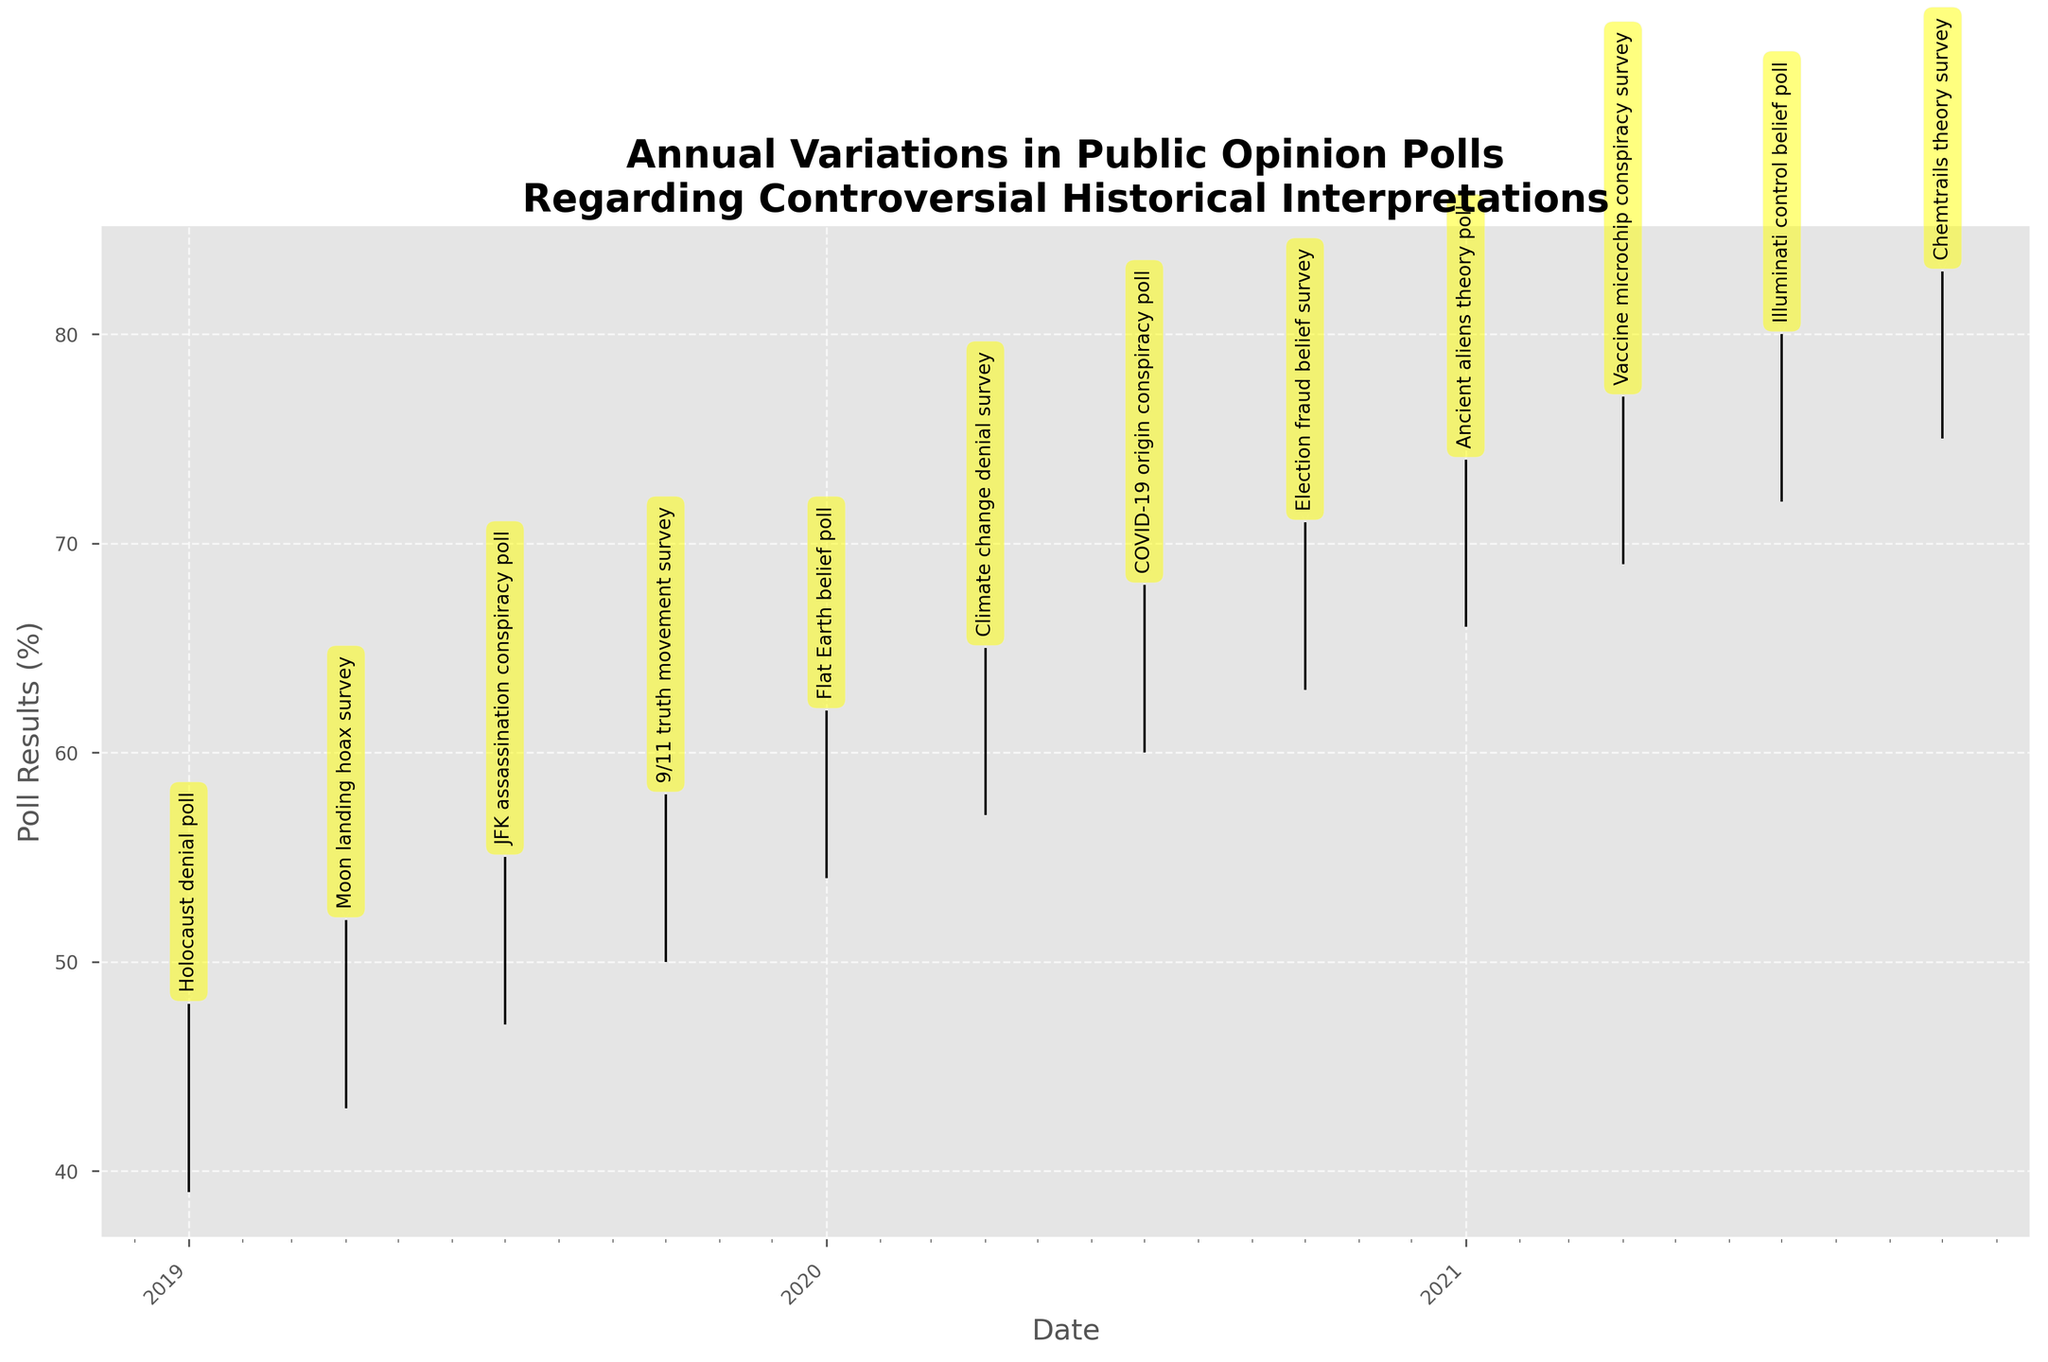What is the title of the figure? The title is typically displayed at the top of the figure. In this case, it states "Annual Variations in Public Opinion Polls Regarding Controversial Historical Interpretations".
Answer: Annual Variations in Public Opinion Polls Regarding Controversial Historical Interpretations What is the highest poll result recorded in the data? To find the highest poll result, look for the highest "High" value in the OHLC chart, which is 83% for the Chemtrails theory survey.
Answer: 83% During which event did the public opinion poll record the lowest "Low" value? Observe the "Low" values across the chart and find the one with the smallest value, which is 39% during the Holocaust denial poll.
Answer: Holocaust denial poll What is the difference between the closing values of the first and last events on the chart? The first event (Holocaust denial poll) has a closing value of 45, and the last event (Chemtrails theory survey) has a closing value of 81. Subtract the former from the latter (81 - 45).
Answer: 36 Which event has the greatest range from the lowest to the highest poll result within its period? Calculating the range (High - Low) for each event, the Moon landing hoax survey has the greatest range: (52 - 43) = 9.
Answer: Moon landing hoax survey How many public opinion polls showed an increase in the closing value compared to the previous event? Comparing the closing values between consecutive events, there are 11 instances of increase (45 to 50, 50 to 53, 53 to 56, 56 to 59, 59 to 63, 63 to 66, 66 to 69, 69 to 72, 72 to 75, 75 to 78, 78 to 81).
Answer: 11 What is the average opening value of polls conducted in the year 2020? The opening values for 2020 are (56, 59, 63, 66). Summing them gives 244, and dividing by the number of events (4) results in an average of 61.
Answer: 61 Which poll experienced the largest increase from its opening value to its closing value within a single event period? Calculating the difference (Close - Open) for each event, the Vaccine microchip conspiracy survey had the largest increase: (75 - 72) = 3.
Answer: Vaccine microchip conspiracy survey What is the median closing value for all the polls in the dataset? To find the median, first list the closing values in ascending order: (45, 50, 53, 56, 59, 63, 66, 69, 72, 75, 78, 81). The median value, being the middle value in an even-numbered list, is the average of the 6th and 7th values: (63 + 66) / 2 = 64.5.
Answer: 64.5 